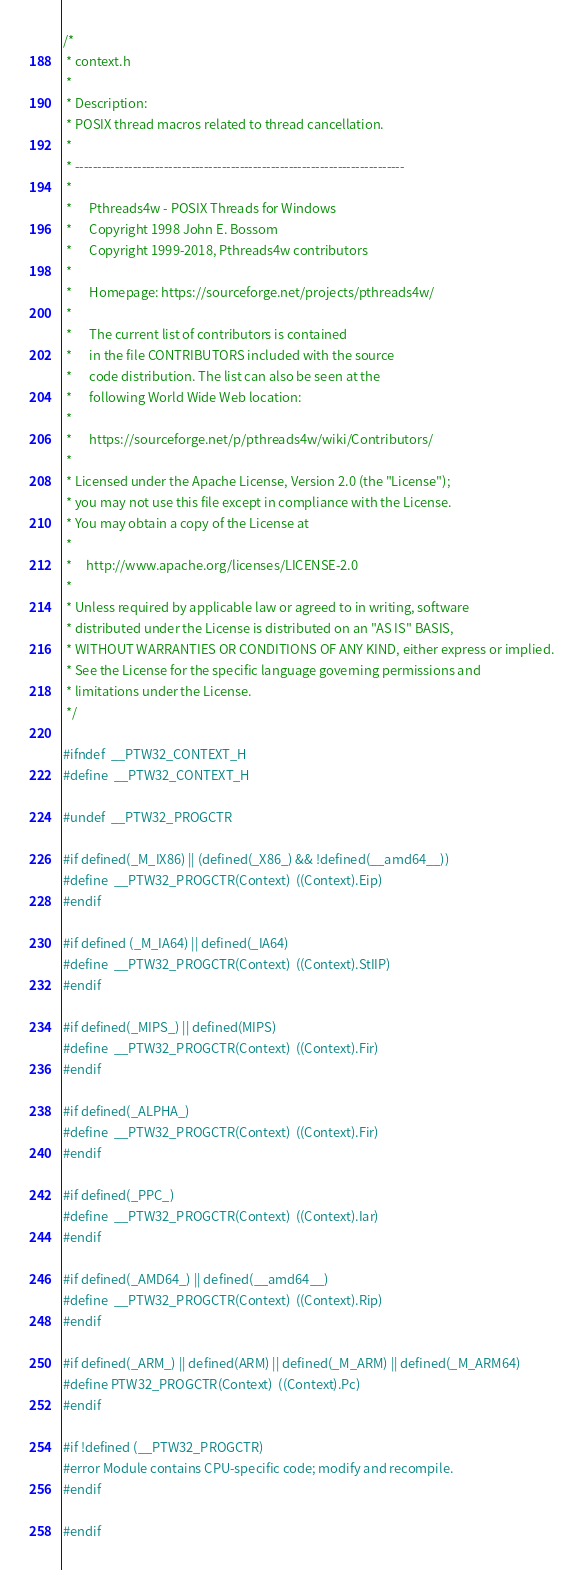Convert code to text. <code><loc_0><loc_0><loc_500><loc_500><_C_>/*
 * context.h
 *
 * Description:
 * POSIX thread macros related to thread cancellation.
 *
 * --------------------------------------------------------------------------
 *
 *      Pthreads4w - POSIX Threads for Windows
 *      Copyright 1998 John E. Bossom
 *      Copyright 1999-2018, Pthreads4w contributors
 *
 *      Homepage: https://sourceforge.net/projects/pthreads4w/
 *
 *      The current list of contributors is contained
 *      in the file CONTRIBUTORS included with the source
 *      code distribution. The list can also be seen at the
 *      following World Wide Web location:
 *
 *      https://sourceforge.net/p/pthreads4w/wiki/Contributors/
 *
 * Licensed under the Apache License, Version 2.0 (the "License");
 * you may not use this file except in compliance with the License.
 * You may obtain a copy of the License at
 *
 *     http://www.apache.org/licenses/LICENSE-2.0
 *
 * Unless required by applicable law or agreed to in writing, software
 * distributed under the License is distributed on an "AS IS" BASIS,
 * WITHOUT WARRANTIES OR CONDITIONS OF ANY KIND, either express or implied.
 * See the License for the specific language governing permissions and
 * limitations under the License.
 */

#ifndef  __PTW32_CONTEXT_H
#define  __PTW32_CONTEXT_H

#undef  __PTW32_PROGCTR

#if defined(_M_IX86) || (defined(_X86_) && !defined(__amd64__))
#define  __PTW32_PROGCTR(Context)  ((Context).Eip)
#endif

#if defined (_M_IA64) || defined(_IA64)
#define  __PTW32_PROGCTR(Context)  ((Context).StIIP)
#endif

#if defined(_MIPS_) || defined(MIPS)
#define  __PTW32_PROGCTR(Context)  ((Context).Fir)
#endif

#if defined(_ALPHA_)
#define  __PTW32_PROGCTR(Context)  ((Context).Fir)
#endif

#if defined(_PPC_)
#define  __PTW32_PROGCTR(Context)  ((Context).Iar)
#endif

#if defined(_AMD64_) || defined(__amd64__)
#define  __PTW32_PROGCTR(Context)  ((Context).Rip)
#endif

#if defined(_ARM_) || defined(ARM) || defined(_M_ARM) || defined(_M_ARM64)
#define PTW32_PROGCTR(Context)  ((Context).Pc)
#endif

#if !defined (__PTW32_PROGCTR)
#error Module contains CPU-specific code; modify and recompile.
#endif

#endif
</code> 